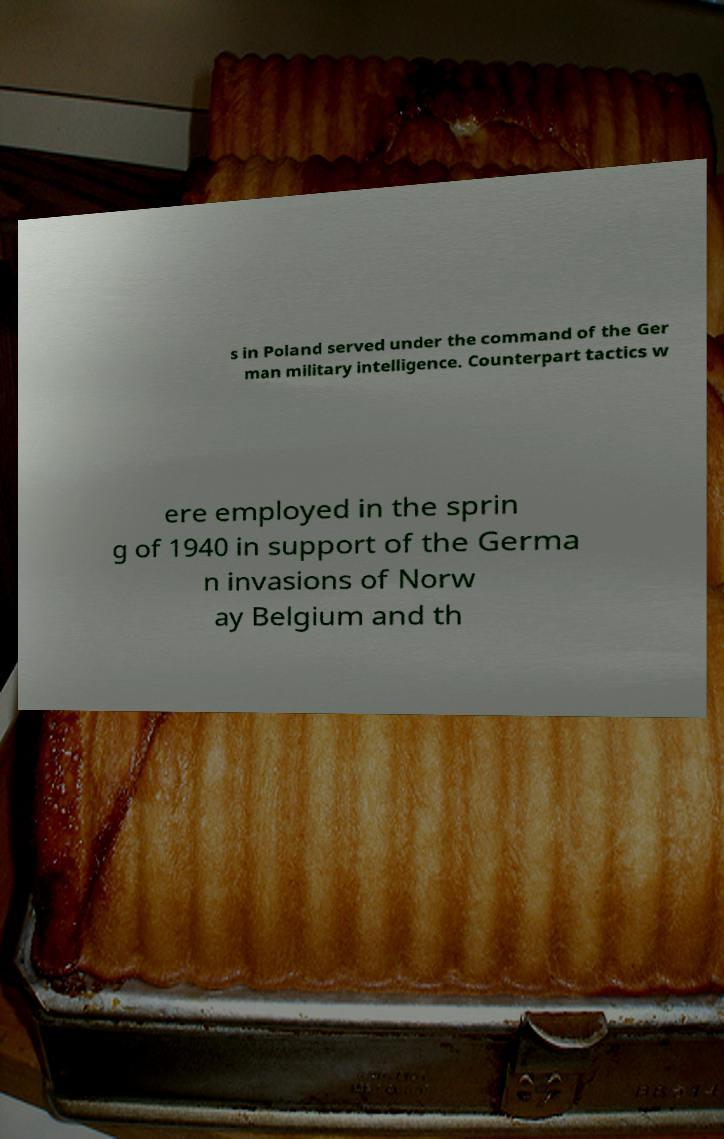For documentation purposes, I need the text within this image transcribed. Could you provide that? s in Poland served under the command of the Ger man military intelligence. Counterpart tactics w ere employed in the sprin g of 1940 in support of the Germa n invasions of Norw ay Belgium and th 